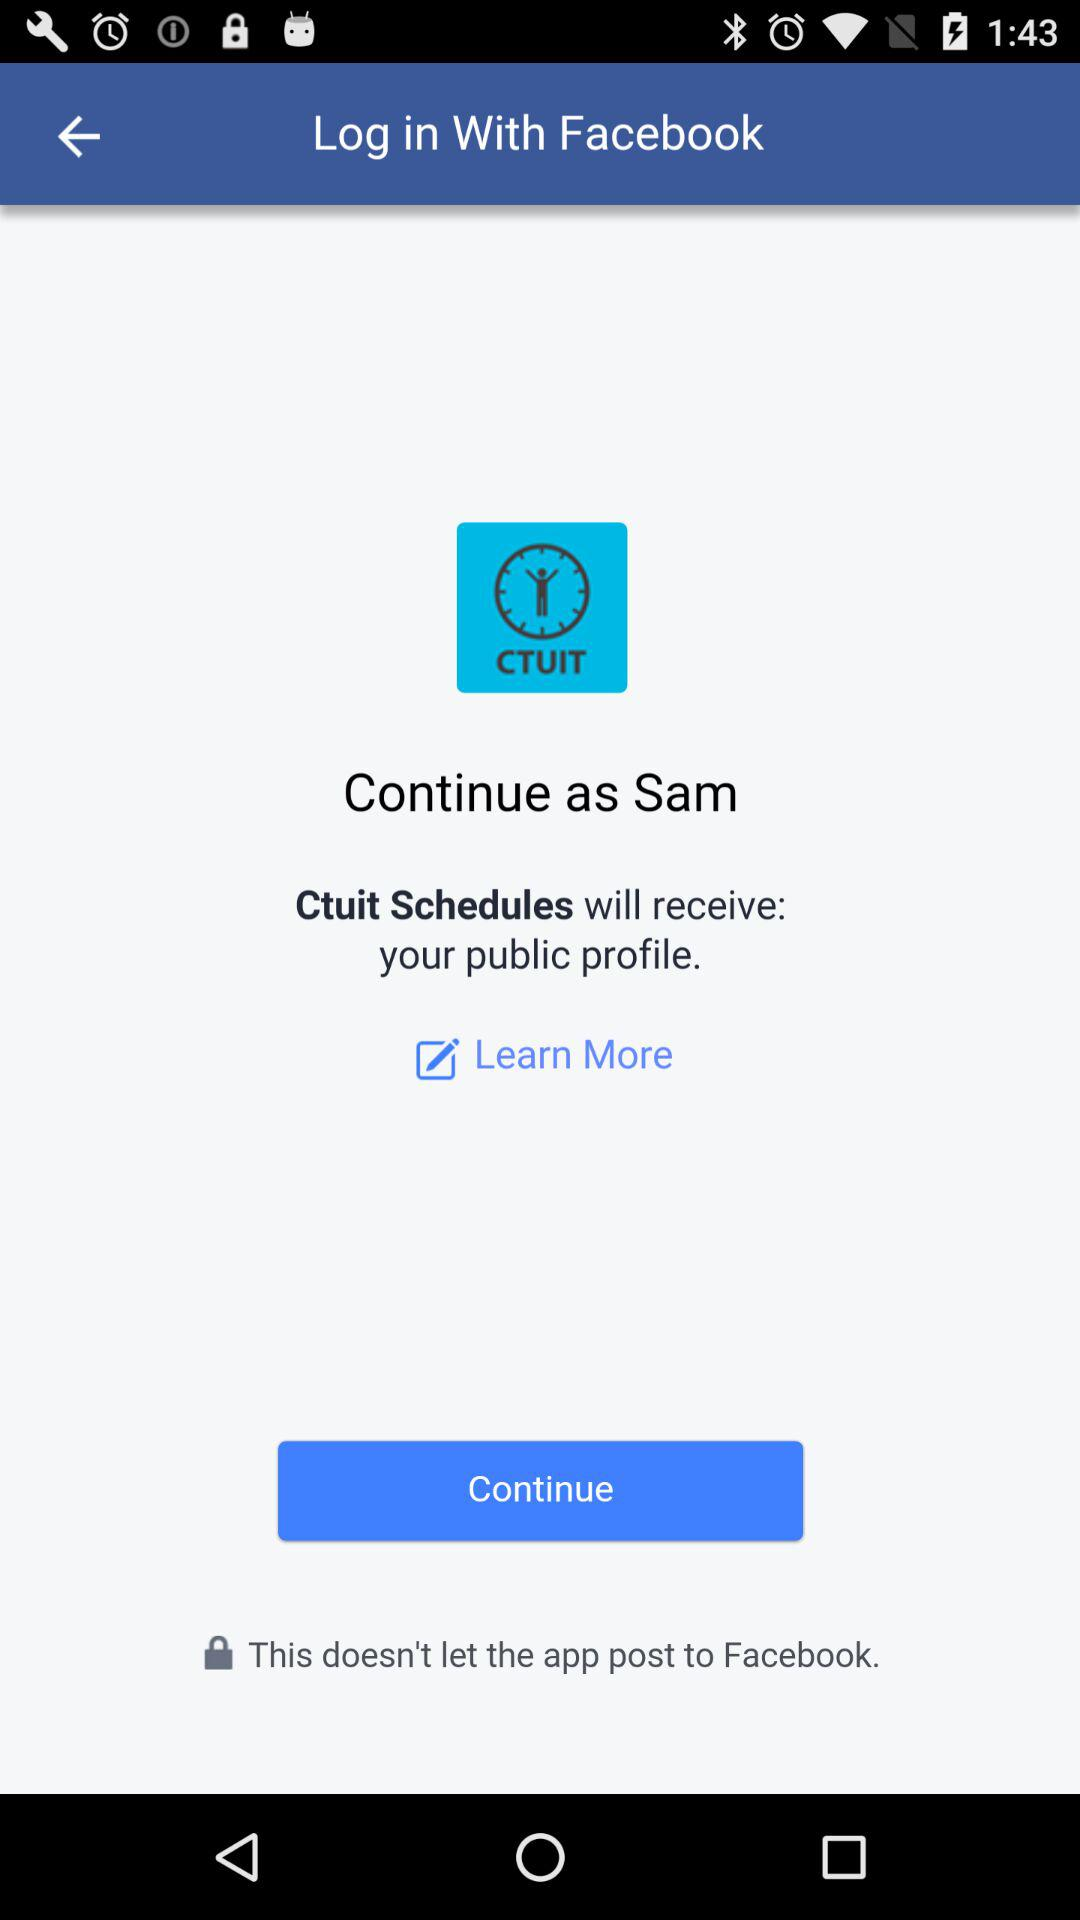What is the version of this application?
When the provided information is insufficient, respond with <no answer>. <no answer> 